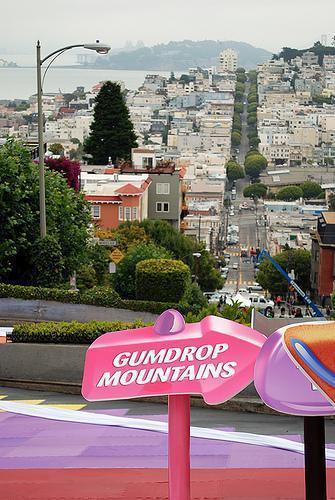How many boats can be seen?
Give a very brief answer. 0. 